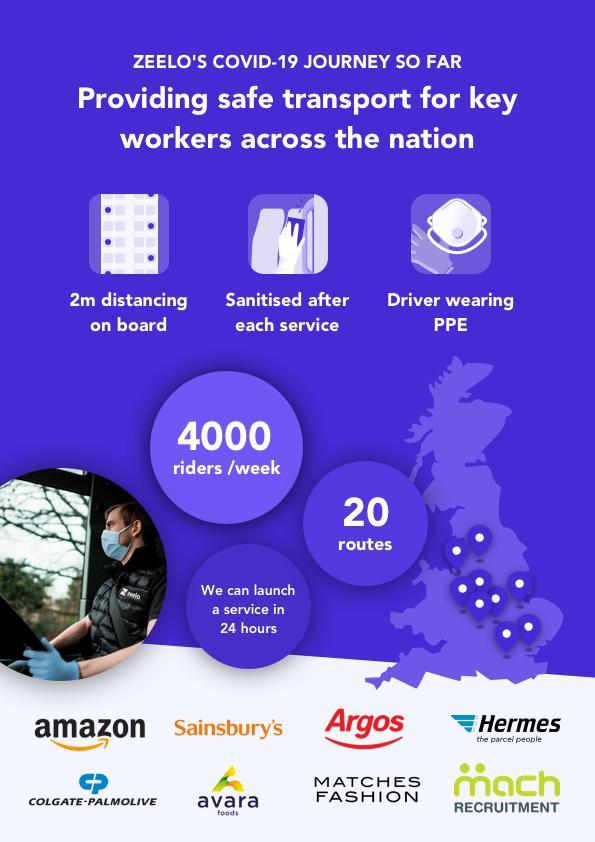How many companies does Zeelo provide transport services for?
Answer the question with a short phrase. 8 